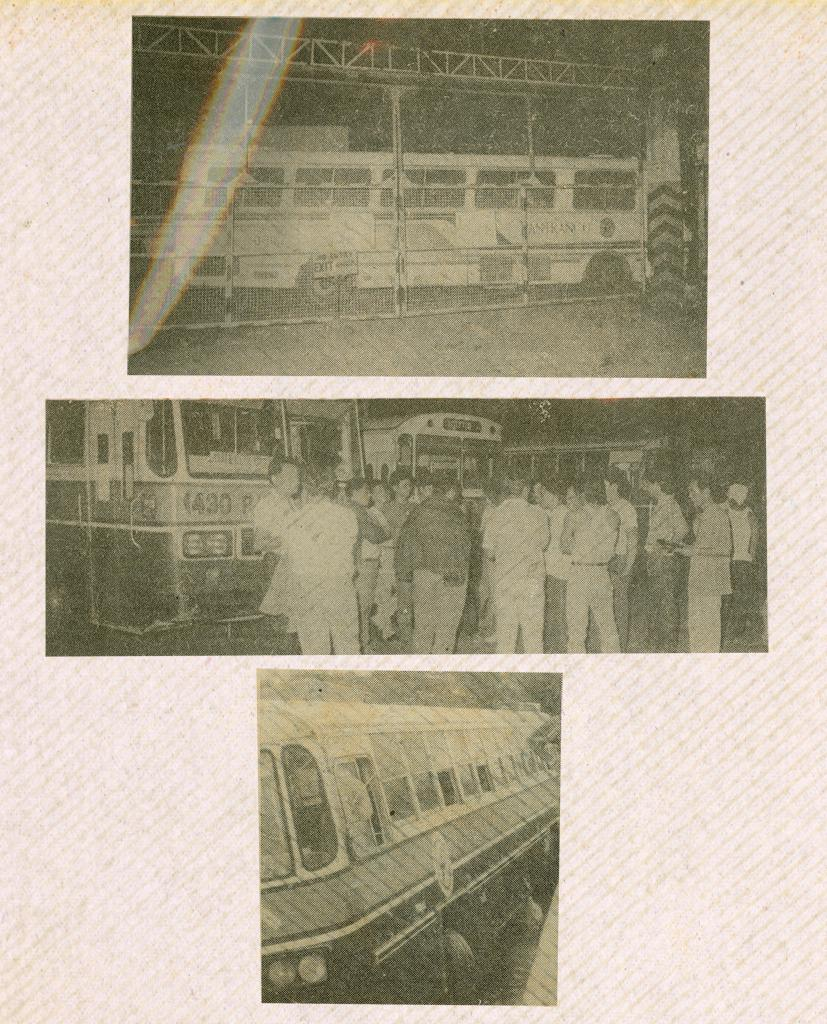What type of images are present in the image? There are three black and white photographs in the image. What can be seen in the photographs? In the photographs, there are buses, metal rods, and people standing. What type of houses can be seen in the photographs? There are no houses present in the photographs; they depict buses, metal rods, and people standing. What attraction is visible in the photographs? There is no specific attraction visible in the photographs; they depict buses, metal rods, and people standing. 